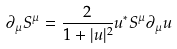<formula> <loc_0><loc_0><loc_500><loc_500>\partial _ { \mu } S ^ { \mu } = \frac { 2 } { 1 + | u | ^ { 2 } } u ^ { * } S ^ { \mu } \partial _ { \mu } u</formula> 